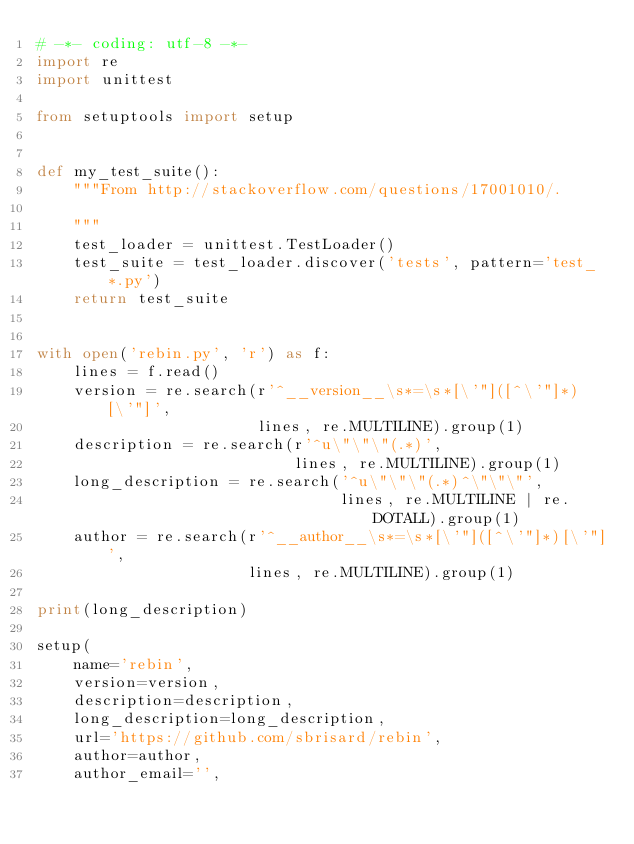<code> <loc_0><loc_0><loc_500><loc_500><_Python_># -*- coding: utf-8 -*-
import re
import unittest

from setuptools import setup


def my_test_suite():
    """From http://stackoverflow.com/questions/17001010/.

    """
    test_loader = unittest.TestLoader()
    test_suite = test_loader.discover('tests', pattern='test_*.py')
    return test_suite


with open('rebin.py', 'r') as f:
    lines = f.read()
    version = re.search(r'^__version__\s*=\s*[\'"]([^\'"]*)[\'"]',
                        lines, re.MULTILINE).group(1)
    description = re.search(r'^u\"\"\"(.*)',
                            lines, re.MULTILINE).group(1)
    long_description = re.search('^u\"\"\"(.*)^\"\"\"',
                                 lines, re.MULTILINE | re.DOTALL).group(1)
    author = re.search(r'^__author__\s*=\s*[\'"]([^\'"]*)[\'"]',
                       lines, re.MULTILINE).group(1)

print(long_description)

setup(
    name='rebin',
    version=version,
    description=description,
    long_description=long_description,
    url='https://github.com/sbrisard/rebin',
    author=author,
    author_email='',</code> 